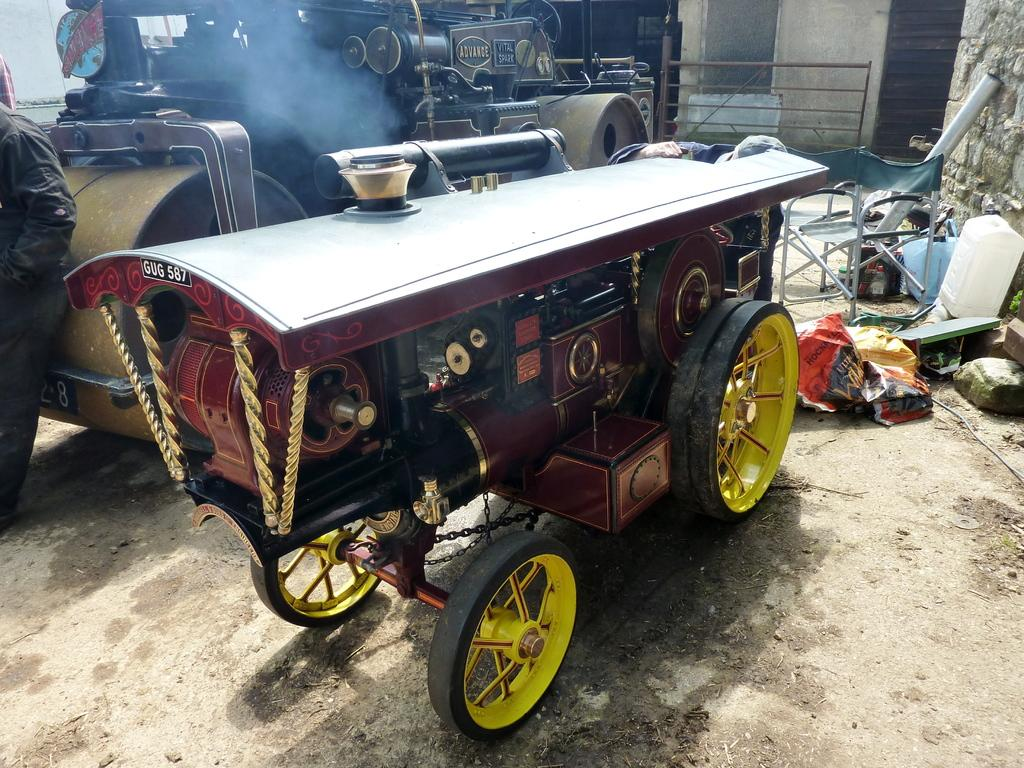What types of vehicles are in the image? The image contains vehicles, but the specific types are not mentioned. What is the purpose of the wall in the image? The purpose of the wall is not clear from the image, but it could be a structural element or a boundary. What is the chair used for in the image? The purpose of the chair is not clear from the image, but it could be for sitting or as a decorative element. Can you describe any other objects in the image? There are some other objects in the image, but their specific details are not mentioned. Where is the secretary sitting in the image? There is no secretary present in the image. What type of toothpaste is used in the image? There is no toothpaste present in the image. 